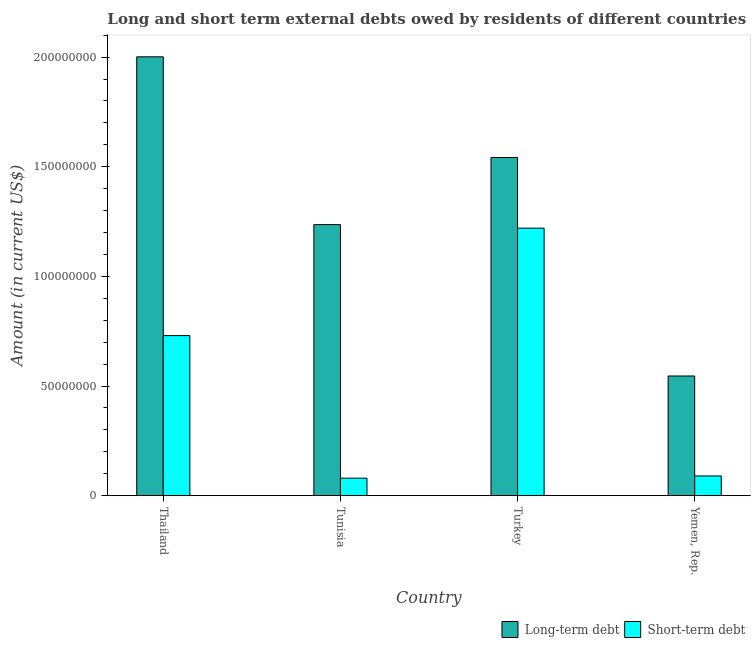How many different coloured bars are there?
Keep it short and to the point. 2. How many groups of bars are there?
Offer a terse response. 4. How many bars are there on the 2nd tick from the left?
Provide a short and direct response. 2. How many bars are there on the 3rd tick from the right?
Keep it short and to the point. 2. What is the label of the 4th group of bars from the left?
Provide a short and direct response. Yemen, Rep. What is the short-term debts owed by residents in Yemen, Rep.?
Ensure brevity in your answer.  9.00e+06. Across all countries, what is the maximum short-term debts owed by residents?
Provide a succinct answer. 1.22e+08. Across all countries, what is the minimum short-term debts owed by residents?
Give a very brief answer. 8.00e+06. In which country was the long-term debts owed by residents minimum?
Offer a very short reply. Yemen, Rep. What is the total long-term debts owed by residents in the graph?
Provide a short and direct response. 5.33e+08. What is the difference between the short-term debts owed by residents in Thailand and that in Yemen, Rep.?
Your answer should be compact. 6.40e+07. What is the difference between the short-term debts owed by residents in Thailand and the long-term debts owed by residents in Turkey?
Your response must be concise. -8.12e+07. What is the average long-term debts owed by residents per country?
Ensure brevity in your answer.  1.33e+08. What is the difference between the long-term debts owed by residents and short-term debts owed by residents in Yemen, Rep.?
Make the answer very short. 4.56e+07. In how many countries, is the long-term debts owed by residents greater than 180000000 US$?
Your answer should be very brief. 1. What is the ratio of the short-term debts owed by residents in Thailand to that in Tunisia?
Your answer should be very brief. 9.12. Is the difference between the short-term debts owed by residents in Thailand and Tunisia greater than the difference between the long-term debts owed by residents in Thailand and Tunisia?
Your answer should be compact. No. What is the difference between the highest and the second highest short-term debts owed by residents?
Make the answer very short. 4.90e+07. What is the difference between the highest and the lowest short-term debts owed by residents?
Make the answer very short. 1.14e+08. In how many countries, is the short-term debts owed by residents greater than the average short-term debts owed by residents taken over all countries?
Provide a short and direct response. 2. Is the sum of the short-term debts owed by residents in Tunisia and Yemen, Rep. greater than the maximum long-term debts owed by residents across all countries?
Give a very brief answer. No. What does the 1st bar from the left in Thailand represents?
Provide a succinct answer. Long-term debt. What does the 2nd bar from the right in Turkey represents?
Your answer should be compact. Long-term debt. How many bars are there?
Keep it short and to the point. 8. How many countries are there in the graph?
Provide a succinct answer. 4. Are the values on the major ticks of Y-axis written in scientific E-notation?
Your answer should be compact. No. How many legend labels are there?
Keep it short and to the point. 2. How are the legend labels stacked?
Ensure brevity in your answer.  Horizontal. What is the title of the graph?
Make the answer very short. Long and short term external debts owed by residents of different countries. What is the label or title of the X-axis?
Give a very brief answer. Country. What is the label or title of the Y-axis?
Give a very brief answer. Amount (in current US$). What is the Amount (in current US$) in Long-term debt in Thailand?
Provide a short and direct response. 2.00e+08. What is the Amount (in current US$) of Short-term debt in Thailand?
Ensure brevity in your answer.  7.30e+07. What is the Amount (in current US$) of Long-term debt in Tunisia?
Offer a very short reply. 1.24e+08. What is the Amount (in current US$) of Short-term debt in Tunisia?
Offer a very short reply. 8.00e+06. What is the Amount (in current US$) of Long-term debt in Turkey?
Offer a terse response. 1.54e+08. What is the Amount (in current US$) of Short-term debt in Turkey?
Give a very brief answer. 1.22e+08. What is the Amount (in current US$) in Long-term debt in Yemen, Rep.?
Your answer should be compact. 5.46e+07. What is the Amount (in current US$) in Short-term debt in Yemen, Rep.?
Give a very brief answer. 9.00e+06. Across all countries, what is the maximum Amount (in current US$) in Long-term debt?
Offer a very short reply. 2.00e+08. Across all countries, what is the maximum Amount (in current US$) of Short-term debt?
Provide a short and direct response. 1.22e+08. Across all countries, what is the minimum Amount (in current US$) in Long-term debt?
Your response must be concise. 5.46e+07. What is the total Amount (in current US$) in Long-term debt in the graph?
Give a very brief answer. 5.33e+08. What is the total Amount (in current US$) of Short-term debt in the graph?
Make the answer very short. 2.12e+08. What is the difference between the Amount (in current US$) in Long-term debt in Thailand and that in Tunisia?
Give a very brief answer. 7.65e+07. What is the difference between the Amount (in current US$) in Short-term debt in Thailand and that in Tunisia?
Make the answer very short. 6.50e+07. What is the difference between the Amount (in current US$) in Long-term debt in Thailand and that in Turkey?
Give a very brief answer. 4.59e+07. What is the difference between the Amount (in current US$) in Short-term debt in Thailand and that in Turkey?
Your answer should be compact. -4.90e+07. What is the difference between the Amount (in current US$) in Long-term debt in Thailand and that in Yemen, Rep.?
Make the answer very short. 1.46e+08. What is the difference between the Amount (in current US$) in Short-term debt in Thailand and that in Yemen, Rep.?
Offer a very short reply. 6.40e+07. What is the difference between the Amount (in current US$) in Long-term debt in Tunisia and that in Turkey?
Your response must be concise. -3.06e+07. What is the difference between the Amount (in current US$) of Short-term debt in Tunisia and that in Turkey?
Provide a succinct answer. -1.14e+08. What is the difference between the Amount (in current US$) of Long-term debt in Tunisia and that in Yemen, Rep.?
Keep it short and to the point. 6.90e+07. What is the difference between the Amount (in current US$) of Long-term debt in Turkey and that in Yemen, Rep.?
Your answer should be compact. 9.96e+07. What is the difference between the Amount (in current US$) of Short-term debt in Turkey and that in Yemen, Rep.?
Your response must be concise. 1.13e+08. What is the difference between the Amount (in current US$) of Long-term debt in Thailand and the Amount (in current US$) of Short-term debt in Tunisia?
Provide a short and direct response. 1.92e+08. What is the difference between the Amount (in current US$) in Long-term debt in Thailand and the Amount (in current US$) in Short-term debt in Turkey?
Your response must be concise. 7.81e+07. What is the difference between the Amount (in current US$) of Long-term debt in Thailand and the Amount (in current US$) of Short-term debt in Yemen, Rep.?
Make the answer very short. 1.91e+08. What is the difference between the Amount (in current US$) of Long-term debt in Tunisia and the Amount (in current US$) of Short-term debt in Turkey?
Offer a very short reply. 1.62e+06. What is the difference between the Amount (in current US$) in Long-term debt in Tunisia and the Amount (in current US$) in Short-term debt in Yemen, Rep.?
Offer a very short reply. 1.15e+08. What is the difference between the Amount (in current US$) in Long-term debt in Turkey and the Amount (in current US$) in Short-term debt in Yemen, Rep.?
Ensure brevity in your answer.  1.45e+08. What is the average Amount (in current US$) in Long-term debt per country?
Offer a terse response. 1.33e+08. What is the average Amount (in current US$) of Short-term debt per country?
Give a very brief answer. 5.30e+07. What is the difference between the Amount (in current US$) in Long-term debt and Amount (in current US$) in Short-term debt in Thailand?
Offer a terse response. 1.27e+08. What is the difference between the Amount (in current US$) of Long-term debt and Amount (in current US$) of Short-term debt in Tunisia?
Ensure brevity in your answer.  1.16e+08. What is the difference between the Amount (in current US$) of Long-term debt and Amount (in current US$) of Short-term debt in Turkey?
Keep it short and to the point. 3.22e+07. What is the difference between the Amount (in current US$) in Long-term debt and Amount (in current US$) in Short-term debt in Yemen, Rep.?
Your answer should be compact. 4.56e+07. What is the ratio of the Amount (in current US$) in Long-term debt in Thailand to that in Tunisia?
Provide a short and direct response. 1.62. What is the ratio of the Amount (in current US$) in Short-term debt in Thailand to that in Tunisia?
Offer a terse response. 9.12. What is the ratio of the Amount (in current US$) of Long-term debt in Thailand to that in Turkey?
Offer a very short reply. 1.3. What is the ratio of the Amount (in current US$) in Short-term debt in Thailand to that in Turkey?
Provide a succinct answer. 0.6. What is the ratio of the Amount (in current US$) in Long-term debt in Thailand to that in Yemen, Rep.?
Ensure brevity in your answer.  3.67. What is the ratio of the Amount (in current US$) in Short-term debt in Thailand to that in Yemen, Rep.?
Make the answer very short. 8.11. What is the ratio of the Amount (in current US$) in Long-term debt in Tunisia to that in Turkey?
Your answer should be very brief. 0.8. What is the ratio of the Amount (in current US$) in Short-term debt in Tunisia to that in Turkey?
Your answer should be very brief. 0.07. What is the ratio of the Amount (in current US$) in Long-term debt in Tunisia to that in Yemen, Rep.?
Provide a succinct answer. 2.26. What is the ratio of the Amount (in current US$) in Long-term debt in Turkey to that in Yemen, Rep.?
Provide a short and direct response. 2.83. What is the ratio of the Amount (in current US$) of Short-term debt in Turkey to that in Yemen, Rep.?
Your answer should be very brief. 13.56. What is the difference between the highest and the second highest Amount (in current US$) of Long-term debt?
Your response must be concise. 4.59e+07. What is the difference between the highest and the second highest Amount (in current US$) of Short-term debt?
Your answer should be compact. 4.90e+07. What is the difference between the highest and the lowest Amount (in current US$) of Long-term debt?
Your answer should be very brief. 1.46e+08. What is the difference between the highest and the lowest Amount (in current US$) in Short-term debt?
Provide a succinct answer. 1.14e+08. 